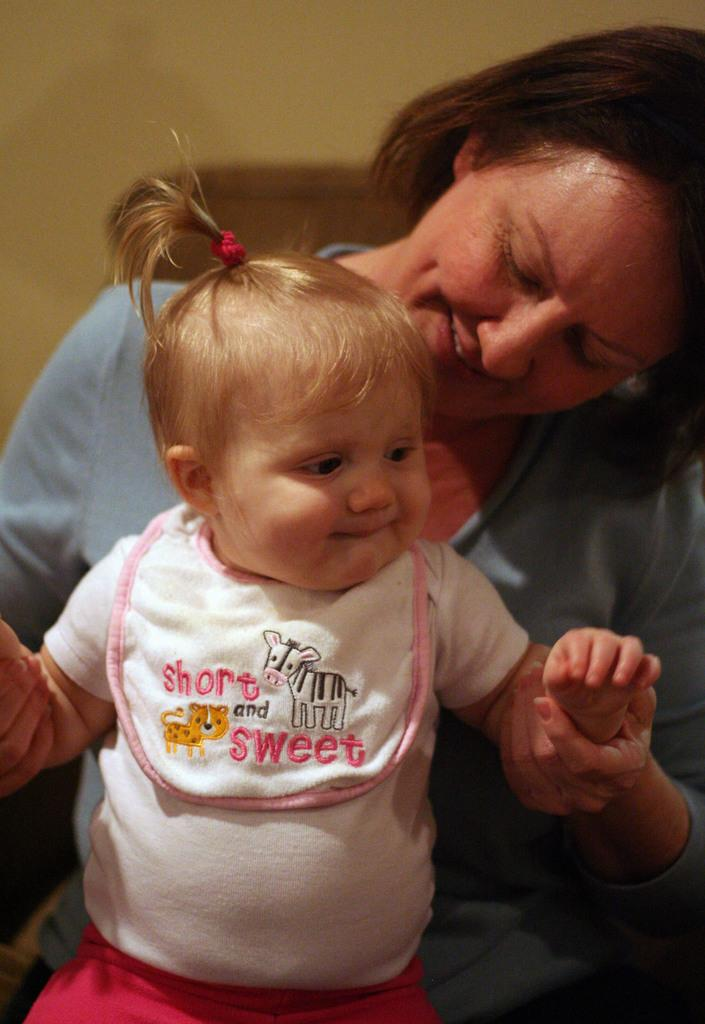Who is the main subject in the image? There is a woman in the image. What is the woman doing in the image? The woman is holding a kid. What is the woman wearing in the image? The woman is wearing a blue top. What is the kid wearing in the image? The kid is wearing a white top and a red skirt. What type of tax can be seen in the image? There is no tax present in the image; it features a woman holding a kid. What letters are visible on the woman's clothing in the image? There are no letters visible on the woman's clothing in the image. 